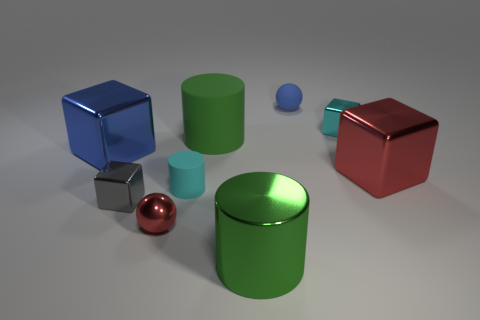What color is the other sphere that is the same size as the blue rubber sphere?
Offer a very short reply. Red. There is a big thing on the right side of the small matte ball; what number of metallic blocks are in front of it?
Your answer should be compact. 1. What number of shiny objects are behind the big red thing and on the left side of the cyan metal object?
Give a very brief answer. 1. How many things are either big green objects in front of the tiny gray shiny block or large cylinders that are in front of the tiny cylinder?
Keep it short and to the point. 1. What number of other objects are there of the same size as the red sphere?
Keep it short and to the point. 4. The small rubber thing in front of the big blue object left of the large red metal cube is what shape?
Give a very brief answer. Cylinder. Does the small block right of the large green metallic object have the same color as the big cylinder that is left of the large green metal object?
Keep it short and to the point. No. Is there anything else that is the same color as the large rubber cylinder?
Your response must be concise. Yes. What is the color of the big shiny cylinder?
Give a very brief answer. Green. Are there any balls?
Your answer should be very brief. Yes. 